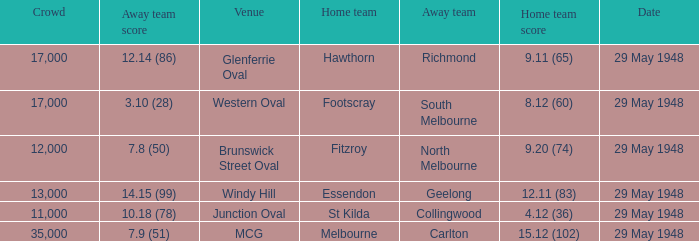In the match where north melbourne was the away team, how much did the home team score? 9.20 (74). 